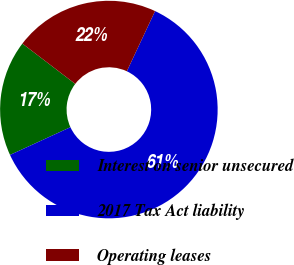Convert chart to OTSL. <chart><loc_0><loc_0><loc_500><loc_500><pie_chart><fcel>Interest on senior unsecured<fcel>2017 Tax Act liability<fcel>Operating leases<nl><fcel>17.22%<fcel>61.17%<fcel>21.61%<nl></chart> 